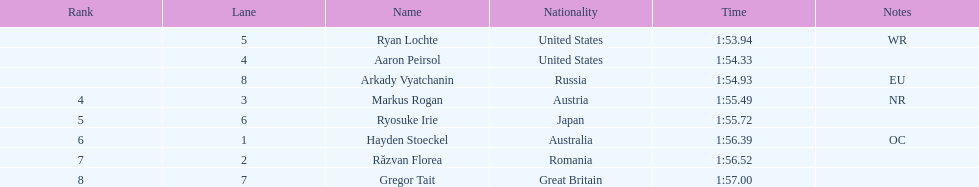Which rival was the final one to rank? Gregor Tait. Can you parse all the data within this table? {'header': ['Rank', 'Lane', 'Name', 'Nationality', 'Time', 'Notes'], 'rows': [['', '5', 'Ryan Lochte', 'United States', '1:53.94', 'WR'], ['', '4', 'Aaron Peirsol', 'United States', '1:54.33', ''], ['', '8', 'Arkady Vyatchanin', 'Russia', '1:54.93', 'EU'], ['4', '3', 'Markus Rogan', 'Austria', '1:55.49', 'NR'], ['5', '6', 'Ryosuke Irie', 'Japan', '1:55.72', ''], ['6', '1', 'Hayden Stoeckel', 'Australia', '1:56.39', 'OC'], ['7', '2', 'Răzvan Florea', 'Romania', '1:56.52', ''], ['8', '7', 'Gregor Tait', 'Great Britain', '1:57.00', '']]} 